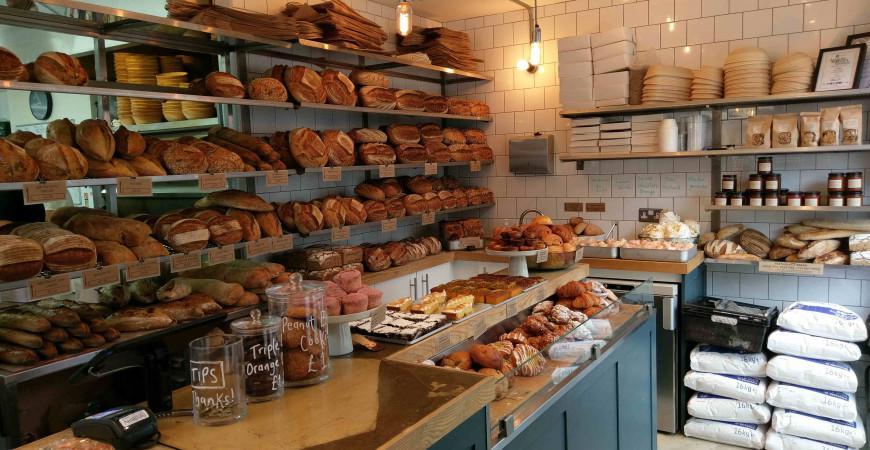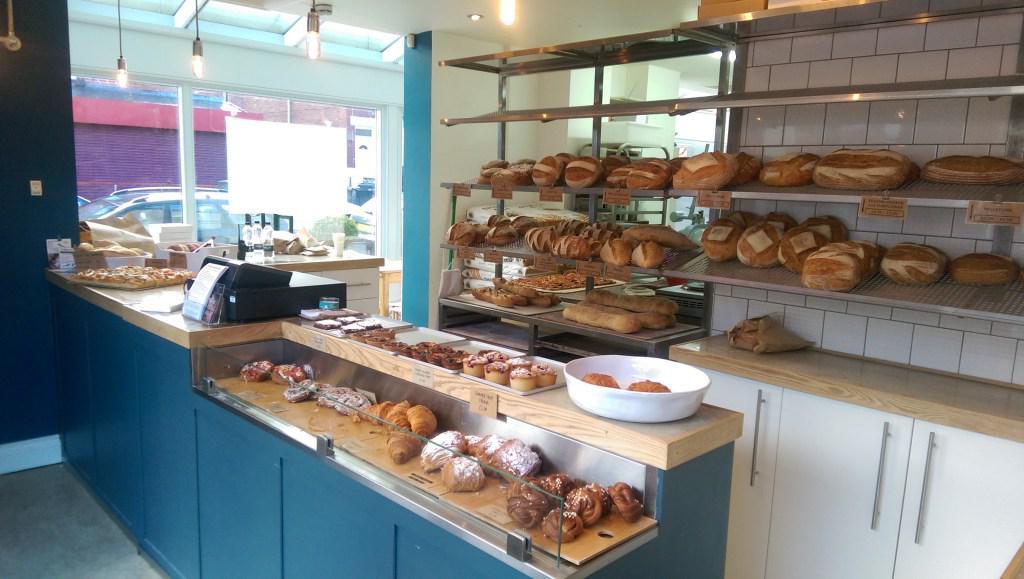The first image is the image on the left, the second image is the image on the right. Analyze the images presented: Is the assertion "An outside view of the Forge Bakehouse." valid? Answer yes or no. No. The first image is the image on the left, the second image is the image on the right. Given the left and right images, does the statement "Both images are of the outside of the store." hold true? Answer yes or no. No. 